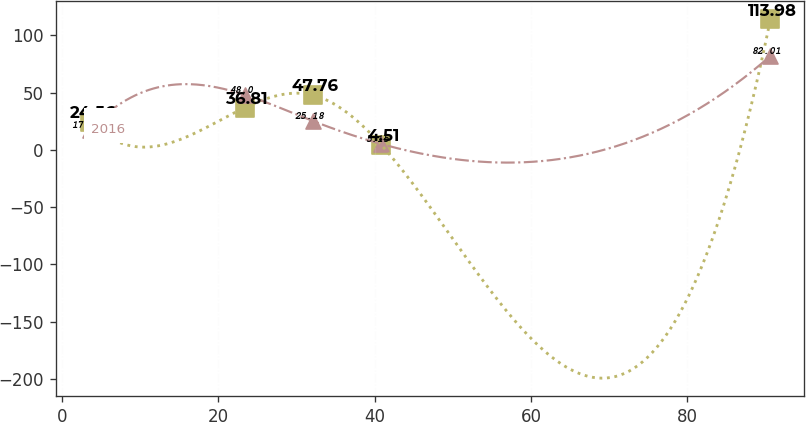Convert chart to OTSL. <chart><loc_0><loc_0><loc_500><loc_500><line_chart><ecel><fcel>2017<fcel>2016<nl><fcel>3.53<fcel>24.56<fcel>17.49<nl><fcel>23.38<fcel>36.81<fcel>48<nl><fcel>32.09<fcel>47.76<fcel>25.18<nl><fcel>40.8<fcel>4.51<fcel>5.15<nl><fcel>90.61<fcel>113.98<fcel>82.01<nl></chart> 